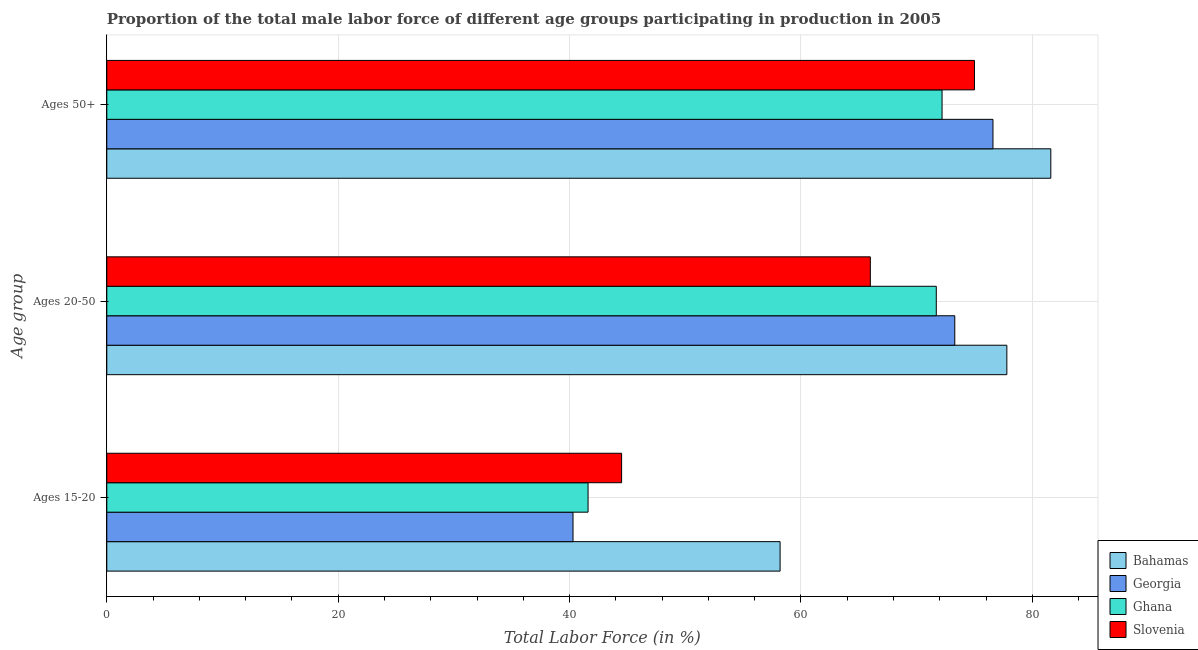How many groups of bars are there?
Ensure brevity in your answer.  3. How many bars are there on the 3rd tick from the bottom?
Your answer should be very brief. 4. What is the label of the 1st group of bars from the top?
Give a very brief answer. Ages 50+. What is the percentage of male labor force above age 50 in Ghana?
Ensure brevity in your answer.  72.2. Across all countries, what is the maximum percentage of male labor force within the age group 20-50?
Keep it short and to the point. 77.8. Across all countries, what is the minimum percentage of male labor force above age 50?
Your answer should be very brief. 72.2. In which country was the percentage of male labor force within the age group 20-50 maximum?
Offer a terse response. Bahamas. In which country was the percentage of male labor force within the age group 15-20 minimum?
Give a very brief answer. Georgia. What is the total percentage of male labor force within the age group 15-20 in the graph?
Your answer should be very brief. 184.6. What is the difference between the percentage of male labor force within the age group 20-50 in Georgia and that in Slovenia?
Keep it short and to the point. 7.3. What is the difference between the percentage of male labor force above age 50 in Georgia and the percentage of male labor force within the age group 20-50 in Ghana?
Provide a short and direct response. 4.9. What is the average percentage of male labor force above age 50 per country?
Give a very brief answer. 76.35. What is the ratio of the percentage of male labor force within the age group 20-50 in Bahamas to that in Slovenia?
Make the answer very short. 1.18. Is the percentage of male labor force within the age group 20-50 in Bahamas less than that in Ghana?
Provide a succinct answer. No. What is the difference between the highest and the second highest percentage of male labor force within the age group 15-20?
Give a very brief answer. 13.7. What is the difference between the highest and the lowest percentage of male labor force within the age group 15-20?
Offer a terse response. 17.9. In how many countries, is the percentage of male labor force within the age group 15-20 greater than the average percentage of male labor force within the age group 15-20 taken over all countries?
Your answer should be very brief. 1. What does the 3rd bar from the top in Ages 15-20 represents?
Your answer should be compact. Georgia. What does the 2nd bar from the bottom in Ages 20-50 represents?
Your response must be concise. Georgia. How many bars are there?
Your response must be concise. 12. Does the graph contain any zero values?
Your answer should be very brief. No. Does the graph contain grids?
Offer a very short reply. Yes. How many legend labels are there?
Keep it short and to the point. 4. What is the title of the graph?
Provide a succinct answer. Proportion of the total male labor force of different age groups participating in production in 2005. Does "Sri Lanka" appear as one of the legend labels in the graph?
Provide a succinct answer. No. What is the label or title of the X-axis?
Make the answer very short. Total Labor Force (in %). What is the label or title of the Y-axis?
Your response must be concise. Age group. What is the Total Labor Force (in %) in Bahamas in Ages 15-20?
Your answer should be very brief. 58.2. What is the Total Labor Force (in %) in Georgia in Ages 15-20?
Provide a succinct answer. 40.3. What is the Total Labor Force (in %) of Ghana in Ages 15-20?
Your answer should be very brief. 41.6. What is the Total Labor Force (in %) in Slovenia in Ages 15-20?
Give a very brief answer. 44.5. What is the Total Labor Force (in %) in Bahamas in Ages 20-50?
Your response must be concise. 77.8. What is the Total Labor Force (in %) in Georgia in Ages 20-50?
Offer a terse response. 73.3. What is the Total Labor Force (in %) in Ghana in Ages 20-50?
Provide a succinct answer. 71.7. What is the Total Labor Force (in %) in Bahamas in Ages 50+?
Offer a terse response. 81.6. What is the Total Labor Force (in %) of Georgia in Ages 50+?
Ensure brevity in your answer.  76.6. What is the Total Labor Force (in %) in Ghana in Ages 50+?
Offer a very short reply. 72.2. What is the Total Labor Force (in %) of Slovenia in Ages 50+?
Offer a very short reply. 75. Across all Age group, what is the maximum Total Labor Force (in %) in Bahamas?
Provide a succinct answer. 81.6. Across all Age group, what is the maximum Total Labor Force (in %) in Georgia?
Provide a short and direct response. 76.6. Across all Age group, what is the maximum Total Labor Force (in %) of Ghana?
Give a very brief answer. 72.2. Across all Age group, what is the maximum Total Labor Force (in %) in Slovenia?
Ensure brevity in your answer.  75. Across all Age group, what is the minimum Total Labor Force (in %) in Bahamas?
Keep it short and to the point. 58.2. Across all Age group, what is the minimum Total Labor Force (in %) of Georgia?
Your answer should be compact. 40.3. Across all Age group, what is the minimum Total Labor Force (in %) of Ghana?
Your answer should be compact. 41.6. Across all Age group, what is the minimum Total Labor Force (in %) of Slovenia?
Provide a short and direct response. 44.5. What is the total Total Labor Force (in %) in Bahamas in the graph?
Offer a very short reply. 217.6. What is the total Total Labor Force (in %) of Georgia in the graph?
Give a very brief answer. 190.2. What is the total Total Labor Force (in %) in Ghana in the graph?
Make the answer very short. 185.5. What is the total Total Labor Force (in %) in Slovenia in the graph?
Provide a short and direct response. 185.5. What is the difference between the Total Labor Force (in %) in Bahamas in Ages 15-20 and that in Ages 20-50?
Give a very brief answer. -19.6. What is the difference between the Total Labor Force (in %) of Georgia in Ages 15-20 and that in Ages 20-50?
Your response must be concise. -33. What is the difference between the Total Labor Force (in %) of Ghana in Ages 15-20 and that in Ages 20-50?
Provide a short and direct response. -30.1. What is the difference between the Total Labor Force (in %) in Slovenia in Ages 15-20 and that in Ages 20-50?
Keep it short and to the point. -21.5. What is the difference between the Total Labor Force (in %) of Bahamas in Ages 15-20 and that in Ages 50+?
Provide a short and direct response. -23.4. What is the difference between the Total Labor Force (in %) of Georgia in Ages 15-20 and that in Ages 50+?
Your answer should be compact. -36.3. What is the difference between the Total Labor Force (in %) in Ghana in Ages 15-20 and that in Ages 50+?
Your answer should be very brief. -30.6. What is the difference between the Total Labor Force (in %) of Slovenia in Ages 15-20 and that in Ages 50+?
Keep it short and to the point. -30.5. What is the difference between the Total Labor Force (in %) of Ghana in Ages 20-50 and that in Ages 50+?
Your answer should be compact. -0.5. What is the difference between the Total Labor Force (in %) of Slovenia in Ages 20-50 and that in Ages 50+?
Offer a terse response. -9. What is the difference between the Total Labor Force (in %) in Bahamas in Ages 15-20 and the Total Labor Force (in %) in Georgia in Ages 20-50?
Provide a short and direct response. -15.1. What is the difference between the Total Labor Force (in %) of Bahamas in Ages 15-20 and the Total Labor Force (in %) of Ghana in Ages 20-50?
Your response must be concise. -13.5. What is the difference between the Total Labor Force (in %) of Georgia in Ages 15-20 and the Total Labor Force (in %) of Ghana in Ages 20-50?
Your answer should be compact. -31.4. What is the difference between the Total Labor Force (in %) of Georgia in Ages 15-20 and the Total Labor Force (in %) of Slovenia in Ages 20-50?
Give a very brief answer. -25.7. What is the difference between the Total Labor Force (in %) of Ghana in Ages 15-20 and the Total Labor Force (in %) of Slovenia in Ages 20-50?
Make the answer very short. -24.4. What is the difference between the Total Labor Force (in %) in Bahamas in Ages 15-20 and the Total Labor Force (in %) in Georgia in Ages 50+?
Offer a terse response. -18.4. What is the difference between the Total Labor Force (in %) in Bahamas in Ages 15-20 and the Total Labor Force (in %) in Slovenia in Ages 50+?
Provide a succinct answer. -16.8. What is the difference between the Total Labor Force (in %) in Georgia in Ages 15-20 and the Total Labor Force (in %) in Ghana in Ages 50+?
Your response must be concise. -31.9. What is the difference between the Total Labor Force (in %) of Georgia in Ages 15-20 and the Total Labor Force (in %) of Slovenia in Ages 50+?
Keep it short and to the point. -34.7. What is the difference between the Total Labor Force (in %) in Ghana in Ages 15-20 and the Total Labor Force (in %) in Slovenia in Ages 50+?
Keep it short and to the point. -33.4. What is the difference between the Total Labor Force (in %) of Bahamas in Ages 20-50 and the Total Labor Force (in %) of Georgia in Ages 50+?
Keep it short and to the point. 1.2. What is the difference between the Total Labor Force (in %) in Bahamas in Ages 20-50 and the Total Labor Force (in %) in Slovenia in Ages 50+?
Ensure brevity in your answer.  2.8. What is the difference between the Total Labor Force (in %) in Georgia in Ages 20-50 and the Total Labor Force (in %) in Ghana in Ages 50+?
Your answer should be very brief. 1.1. What is the difference between the Total Labor Force (in %) of Georgia in Ages 20-50 and the Total Labor Force (in %) of Slovenia in Ages 50+?
Make the answer very short. -1.7. What is the difference between the Total Labor Force (in %) of Ghana in Ages 20-50 and the Total Labor Force (in %) of Slovenia in Ages 50+?
Provide a succinct answer. -3.3. What is the average Total Labor Force (in %) in Bahamas per Age group?
Keep it short and to the point. 72.53. What is the average Total Labor Force (in %) in Georgia per Age group?
Provide a succinct answer. 63.4. What is the average Total Labor Force (in %) in Ghana per Age group?
Offer a terse response. 61.83. What is the average Total Labor Force (in %) in Slovenia per Age group?
Your answer should be compact. 61.83. What is the difference between the Total Labor Force (in %) in Bahamas and Total Labor Force (in %) in Ghana in Ages 15-20?
Offer a terse response. 16.6. What is the difference between the Total Labor Force (in %) in Bahamas and Total Labor Force (in %) in Slovenia in Ages 15-20?
Make the answer very short. 13.7. What is the difference between the Total Labor Force (in %) of Georgia and Total Labor Force (in %) of Ghana in Ages 15-20?
Offer a very short reply. -1.3. What is the difference between the Total Labor Force (in %) in Georgia and Total Labor Force (in %) in Slovenia in Ages 15-20?
Offer a terse response. -4.2. What is the difference between the Total Labor Force (in %) in Ghana and Total Labor Force (in %) in Slovenia in Ages 15-20?
Provide a succinct answer. -2.9. What is the difference between the Total Labor Force (in %) in Bahamas and Total Labor Force (in %) in Georgia in Ages 20-50?
Give a very brief answer. 4.5. What is the difference between the Total Labor Force (in %) of Bahamas and Total Labor Force (in %) of Slovenia in Ages 20-50?
Your answer should be very brief. 11.8. What is the difference between the Total Labor Force (in %) of Georgia and Total Labor Force (in %) of Ghana in Ages 20-50?
Your answer should be compact. 1.6. What is the difference between the Total Labor Force (in %) of Georgia and Total Labor Force (in %) of Slovenia in Ages 20-50?
Ensure brevity in your answer.  7.3. What is the difference between the Total Labor Force (in %) in Ghana and Total Labor Force (in %) in Slovenia in Ages 20-50?
Provide a short and direct response. 5.7. What is the difference between the Total Labor Force (in %) of Bahamas and Total Labor Force (in %) of Slovenia in Ages 50+?
Give a very brief answer. 6.6. What is the difference between the Total Labor Force (in %) of Georgia and Total Labor Force (in %) of Ghana in Ages 50+?
Make the answer very short. 4.4. What is the difference between the Total Labor Force (in %) in Georgia and Total Labor Force (in %) in Slovenia in Ages 50+?
Keep it short and to the point. 1.6. What is the difference between the Total Labor Force (in %) of Ghana and Total Labor Force (in %) of Slovenia in Ages 50+?
Keep it short and to the point. -2.8. What is the ratio of the Total Labor Force (in %) of Bahamas in Ages 15-20 to that in Ages 20-50?
Keep it short and to the point. 0.75. What is the ratio of the Total Labor Force (in %) of Georgia in Ages 15-20 to that in Ages 20-50?
Provide a succinct answer. 0.55. What is the ratio of the Total Labor Force (in %) of Ghana in Ages 15-20 to that in Ages 20-50?
Offer a very short reply. 0.58. What is the ratio of the Total Labor Force (in %) of Slovenia in Ages 15-20 to that in Ages 20-50?
Your response must be concise. 0.67. What is the ratio of the Total Labor Force (in %) in Bahamas in Ages 15-20 to that in Ages 50+?
Offer a very short reply. 0.71. What is the ratio of the Total Labor Force (in %) in Georgia in Ages 15-20 to that in Ages 50+?
Your answer should be compact. 0.53. What is the ratio of the Total Labor Force (in %) in Ghana in Ages 15-20 to that in Ages 50+?
Provide a short and direct response. 0.58. What is the ratio of the Total Labor Force (in %) in Slovenia in Ages 15-20 to that in Ages 50+?
Make the answer very short. 0.59. What is the ratio of the Total Labor Force (in %) of Bahamas in Ages 20-50 to that in Ages 50+?
Provide a short and direct response. 0.95. What is the ratio of the Total Labor Force (in %) of Georgia in Ages 20-50 to that in Ages 50+?
Keep it short and to the point. 0.96. What is the ratio of the Total Labor Force (in %) in Ghana in Ages 20-50 to that in Ages 50+?
Your answer should be very brief. 0.99. What is the ratio of the Total Labor Force (in %) of Slovenia in Ages 20-50 to that in Ages 50+?
Provide a succinct answer. 0.88. What is the difference between the highest and the second highest Total Labor Force (in %) of Bahamas?
Give a very brief answer. 3.8. What is the difference between the highest and the second highest Total Labor Force (in %) in Ghana?
Offer a very short reply. 0.5. What is the difference between the highest and the lowest Total Labor Force (in %) in Bahamas?
Ensure brevity in your answer.  23.4. What is the difference between the highest and the lowest Total Labor Force (in %) in Georgia?
Make the answer very short. 36.3. What is the difference between the highest and the lowest Total Labor Force (in %) in Ghana?
Give a very brief answer. 30.6. What is the difference between the highest and the lowest Total Labor Force (in %) in Slovenia?
Make the answer very short. 30.5. 